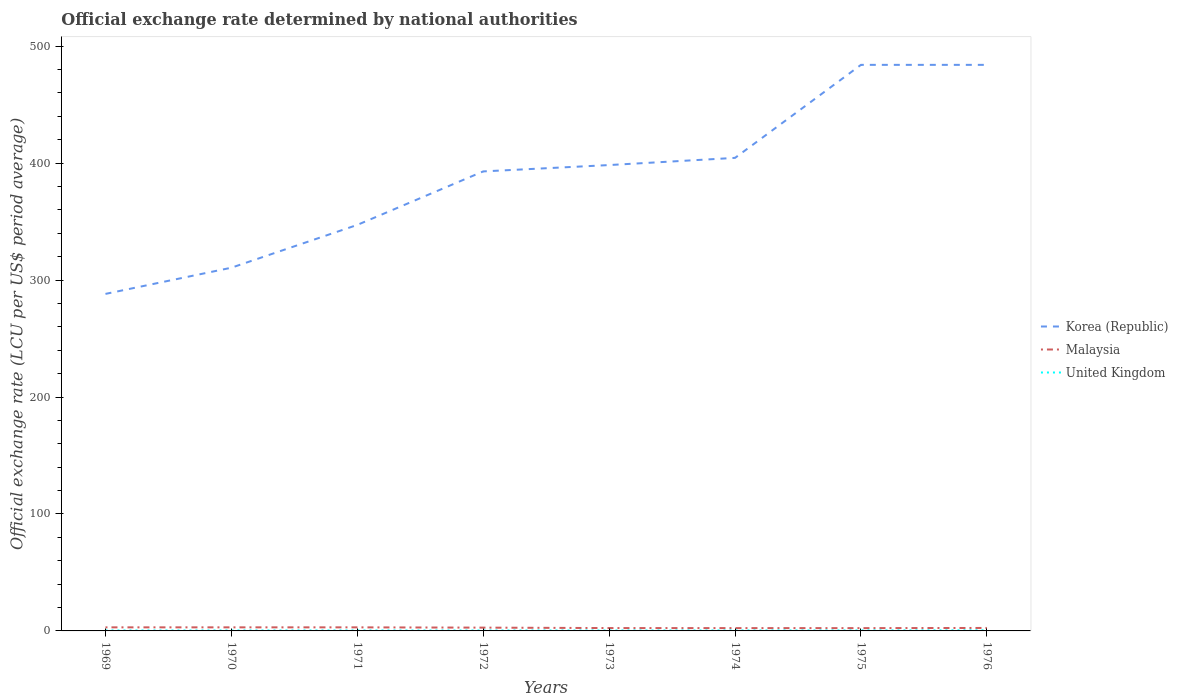How many different coloured lines are there?
Provide a short and direct response. 3. Is the number of lines equal to the number of legend labels?
Offer a very short reply. Yes. Across all years, what is the maximum official exchange rate in Malaysia?
Ensure brevity in your answer.  2.39. In which year was the official exchange rate in Malaysia maximum?
Your answer should be very brief. 1975. What is the total official exchange rate in United Kingdom in the graph?
Ensure brevity in your answer.  -0.02. What is the difference between the highest and the second highest official exchange rate in United Kingdom?
Your response must be concise. 0.16. What is the difference between the highest and the lowest official exchange rate in United Kingdom?
Provide a short and direct response. 2. Is the official exchange rate in Malaysia strictly greater than the official exchange rate in Korea (Republic) over the years?
Your answer should be very brief. Yes. How many years are there in the graph?
Keep it short and to the point. 8. Are the values on the major ticks of Y-axis written in scientific E-notation?
Offer a terse response. No. How many legend labels are there?
Keep it short and to the point. 3. How are the legend labels stacked?
Your response must be concise. Vertical. What is the title of the graph?
Your answer should be compact. Official exchange rate determined by national authorities. What is the label or title of the X-axis?
Your answer should be compact. Years. What is the label or title of the Y-axis?
Your response must be concise. Official exchange rate (LCU per US$ period average). What is the Official exchange rate (LCU per US$ period average) in Korea (Republic) in 1969?
Your response must be concise. 288.16. What is the Official exchange rate (LCU per US$ period average) of Malaysia in 1969?
Ensure brevity in your answer.  3.06. What is the Official exchange rate (LCU per US$ period average) of United Kingdom in 1969?
Provide a succinct answer. 0.42. What is the Official exchange rate (LCU per US$ period average) of Korea (Republic) in 1970?
Ensure brevity in your answer.  310.56. What is the Official exchange rate (LCU per US$ period average) in Malaysia in 1970?
Provide a succinct answer. 3.06. What is the Official exchange rate (LCU per US$ period average) of United Kingdom in 1970?
Provide a short and direct response. 0.42. What is the Official exchange rate (LCU per US$ period average) of Korea (Republic) in 1971?
Offer a terse response. 347.15. What is the Official exchange rate (LCU per US$ period average) in Malaysia in 1971?
Ensure brevity in your answer.  3.05. What is the Official exchange rate (LCU per US$ period average) in United Kingdom in 1971?
Ensure brevity in your answer.  0.41. What is the Official exchange rate (LCU per US$ period average) of Korea (Republic) in 1972?
Provide a short and direct response. 392.89. What is the Official exchange rate (LCU per US$ period average) in Malaysia in 1972?
Make the answer very short. 2.82. What is the Official exchange rate (LCU per US$ period average) in United Kingdom in 1972?
Give a very brief answer. 0.4. What is the Official exchange rate (LCU per US$ period average) in Korea (Republic) in 1973?
Keep it short and to the point. 398.32. What is the Official exchange rate (LCU per US$ period average) in Malaysia in 1973?
Your answer should be very brief. 2.44. What is the Official exchange rate (LCU per US$ period average) of United Kingdom in 1973?
Your response must be concise. 0.41. What is the Official exchange rate (LCU per US$ period average) in Korea (Republic) in 1974?
Provide a short and direct response. 404.47. What is the Official exchange rate (LCU per US$ period average) in Malaysia in 1974?
Your answer should be very brief. 2.41. What is the Official exchange rate (LCU per US$ period average) in United Kingdom in 1974?
Ensure brevity in your answer.  0.43. What is the Official exchange rate (LCU per US$ period average) in Korea (Republic) in 1975?
Offer a very short reply. 484. What is the Official exchange rate (LCU per US$ period average) of Malaysia in 1975?
Offer a terse response. 2.39. What is the Official exchange rate (LCU per US$ period average) of United Kingdom in 1975?
Make the answer very short. 0.45. What is the Official exchange rate (LCU per US$ period average) in Korea (Republic) in 1976?
Your answer should be very brief. 484. What is the Official exchange rate (LCU per US$ period average) in Malaysia in 1976?
Offer a very short reply. 2.54. What is the Official exchange rate (LCU per US$ period average) of United Kingdom in 1976?
Offer a very short reply. 0.56. Across all years, what is the maximum Official exchange rate (LCU per US$ period average) in Korea (Republic)?
Make the answer very short. 484. Across all years, what is the maximum Official exchange rate (LCU per US$ period average) in Malaysia?
Ensure brevity in your answer.  3.06. Across all years, what is the maximum Official exchange rate (LCU per US$ period average) of United Kingdom?
Keep it short and to the point. 0.56. Across all years, what is the minimum Official exchange rate (LCU per US$ period average) of Korea (Republic)?
Your answer should be very brief. 288.16. Across all years, what is the minimum Official exchange rate (LCU per US$ period average) in Malaysia?
Offer a terse response. 2.39. Across all years, what is the minimum Official exchange rate (LCU per US$ period average) of United Kingdom?
Offer a very short reply. 0.4. What is the total Official exchange rate (LCU per US$ period average) in Korea (Republic) in the graph?
Your answer should be very brief. 3109.55. What is the total Official exchange rate (LCU per US$ period average) in Malaysia in the graph?
Your response must be concise. 21.78. What is the total Official exchange rate (LCU per US$ period average) in United Kingdom in the graph?
Keep it short and to the point. 3.49. What is the difference between the Official exchange rate (LCU per US$ period average) in Korea (Republic) in 1969 and that in 1970?
Ensure brevity in your answer.  -22.39. What is the difference between the Official exchange rate (LCU per US$ period average) in Malaysia in 1969 and that in 1970?
Give a very brief answer. 0. What is the difference between the Official exchange rate (LCU per US$ period average) of Korea (Republic) in 1969 and that in 1971?
Make the answer very short. -58.99. What is the difference between the Official exchange rate (LCU per US$ period average) in Malaysia in 1969 and that in 1971?
Make the answer very short. 0.01. What is the difference between the Official exchange rate (LCU per US$ period average) in United Kingdom in 1969 and that in 1971?
Keep it short and to the point. 0.01. What is the difference between the Official exchange rate (LCU per US$ period average) in Korea (Republic) in 1969 and that in 1972?
Give a very brief answer. -104.73. What is the difference between the Official exchange rate (LCU per US$ period average) of Malaysia in 1969 and that in 1972?
Your response must be concise. 0.24. What is the difference between the Official exchange rate (LCU per US$ period average) of United Kingdom in 1969 and that in 1972?
Ensure brevity in your answer.  0.02. What is the difference between the Official exchange rate (LCU per US$ period average) in Korea (Republic) in 1969 and that in 1973?
Offer a very short reply. -110.16. What is the difference between the Official exchange rate (LCU per US$ period average) in Malaysia in 1969 and that in 1973?
Your answer should be compact. 0.62. What is the difference between the Official exchange rate (LCU per US$ period average) in United Kingdom in 1969 and that in 1973?
Offer a very short reply. 0.01. What is the difference between the Official exchange rate (LCU per US$ period average) in Korea (Republic) in 1969 and that in 1974?
Offer a terse response. -116.31. What is the difference between the Official exchange rate (LCU per US$ period average) in Malaysia in 1969 and that in 1974?
Ensure brevity in your answer.  0.65. What is the difference between the Official exchange rate (LCU per US$ period average) in United Kingdom in 1969 and that in 1974?
Provide a short and direct response. -0.01. What is the difference between the Official exchange rate (LCU per US$ period average) of Korea (Republic) in 1969 and that in 1975?
Keep it short and to the point. -195.84. What is the difference between the Official exchange rate (LCU per US$ period average) in Malaysia in 1969 and that in 1975?
Ensure brevity in your answer.  0.67. What is the difference between the Official exchange rate (LCU per US$ period average) of United Kingdom in 1969 and that in 1975?
Your answer should be compact. -0.04. What is the difference between the Official exchange rate (LCU per US$ period average) in Korea (Republic) in 1969 and that in 1976?
Provide a short and direct response. -195.84. What is the difference between the Official exchange rate (LCU per US$ period average) of Malaysia in 1969 and that in 1976?
Give a very brief answer. 0.52. What is the difference between the Official exchange rate (LCU per US$ period average) of United Kingdom in 1969 and that in 1976?
Your answer should be compact. -0.14. What is the difference between the Official exchange rate (LCU per US$ period average) of Korea (Republic) in 1970 and that in 1971?
Keep it short and to the point. -36.59. What is the difference between the Official exchange rate (LCU per US$ period average) of Malaysia in 1970 and that in 1971?
Provide a succinct answer. 0.01. What is the difference between the Official exchange rate (LCU per US$ period average) of United Kingdom in 1970 and that in 1971?
Give a very brief answer. 0.01. What is the difference between the Official exchange rate (LCU per US$ period average) in Korea (Republic) in 1970 and that in 1972?
Keep it short and to the point. -82.34. What is the difference between the Official exchange rate (LCU per US$ period average) of Malaysia in 1970 and that in 1972?
Your answer should be very brief. 0.24. What is the difference between the Official exchange rate (LCU per US$ period average) in United Kingdom in 1970 and that in 1972?
Your answer should be very brief. 0.02. What is the difference between the Official exchange rate (LCU per US$ period average) in Korea (Republic) in 1970 and that in 1973?
Provide a short and direct response. -87.77. What is the difference between the Official exchange rate (LCU per US$ period average) of Malaysia in 1970 and that in 1973?
Offer a very short reply. 0.62. What is the difference between the Official exchange rate (LCU per US$ period average) of United Kingdom in 1970 and that in 1973?
Provide a succinct answer. 0.01. What is the difference between the Official exchange rate (LCU per US$ period average) of Korea (Republic) in 1970 and that in 1974?
Give a very brief answer. -93.92. What is the difference between the Official exchange rate (LCU per US$ period average) in Malaysia in 1970 and that in 1974?
Provide a short and direct response. 0.65. What is the difference between the Official exchange rate (LCU per US$ period average) in United Kingdom in 1970 and that in 1974?
Offer a terse response. -0.01. What is the difference between the Official exchange rate (LCU per US$ period average) of Korea (Republic) in 1970 and that in 1975?
Provide a succinct answer. -173.44. What is the difference between the Official exchange rate (LCU per US$ period average) of Malaysia in 1970 and that in 1975?
Provide a succinct answer. 0.67. What is the difference between the Official exchange rate (LCU per US$ period average) of United Kingdom in 1970 and that in 1975?
Your answer should be compact. -0.04. What is the difference between the Official exchange rate (LCU per US$ period average) of Korea (Republic) in 1970 and that in 1976?
Your answer should be compact. -173.44. What is the difference between the Official exchange rate (LCU per US$ period average) of Malaysia in 1970 and that in 1976?
Ensure brevity in your answer.  0.52. What is the difference between the Official exchange rate (LCU per US$ period average) of United Kingdom in 1970 and that in 1976?
Provide a short and direct response. -0.14. What is the difference between the Official exchange rate (LCU per US$ period average) of Korea (Republic) in 1971 and that in 1972?
Give a very brief answer. -45.75. What is the difference between the Official exchange rate (LCU per US$ period average) of Malaysia in 1971 and that in 1972?
Ensure brevity in your answer.  0.23. What is the difference between the Official exchange rate (LCU per US$ period average) in United Kingdom in 1971 and that in 1972?
Provide a short and direct response. 0.01. What is the difference between the Official exchange rate (LCU per US$ period average) in Korea (Republic) in 1971 and that in 1973?
Provide a short and direct response. -51.17. What is the difference between the Official exchange rate (LCU per US$ period average) in Malaysia in 1971 and that in 1973?
Offer a terse response. 0.61. What is the difference between the Official exchange rate (LCU per US$ period average) in United Kingdom in 1971 and that in 1973?
Provide a short and direct response. 0. What is the difference between the Official exchange rate (LCU per US$ period average) in Korea (Republic) in 1971 and that in 1974?
Give a very brief answer. -57.33. What is the difference between the Official exchange rate (LCU per US$ period average) in Malaysia in 1971 and that in 1974?
Your answer should be compact. 0.65. What is the difference between the Official exchange rate (LCU per US$ period average) of United Kingdom in 1971 and that in 1974?
Ensure brevity in your answer.  -0.02. What is the difference between the Official exchange rate (LCU per US$ period average) in Korea (Republic) in 1971 and that in 1975?
Keep it short and to the point. -136.85. What is the difference between the Official exchange rate (LCU per US$ period average) of Malaysia in 1971 and that in 1975?
Offer a very short reply. 0.66. What is the difference between the Official exchange rate (LCU per US$ period average) in United Kingdom in 1971 and that in 1975?
Provide a short and direct response. -0.04. What is the difference between the Official exchange rate (LCU per US$ period average) in Korea (Republic) in 1971 and that in 1976?
Your answer should be very brief. -136.85. What is the difference between the Official exchange rate (LCU per US$ period average) of Malaysia in 1971 and that in 1976?
Your answer should be compact. 0.51. What is the difference between the Official exchange rate (LCU per US$ period average) of United Kingdom in 1971 and that in 1976?
Offer a very short reply. -0.15. What is the difference between the Official exchange rate (LCU per US$ period average) in Korea (Republic) in 1972 and that in 1973?
Offer a terse response. -5.43. What is the difference between the Official exchange rate (LCU per US$ period average) in Malaysia in 1972 and that in 1973?
Your answer should be compact. 0.38. What is the difference between the Official exchange rate (LCU per US$ period average) in United Kingdom in 1972 and that in 1973?
Your answer should be compact. -0.01. What is the difference between the Official exchange rate (LCU per US$ period average) in Korea (Republic) in 1972 and that in 1974?
Offer a terse response. -11.58. What is the difference between the Official exchange rate (LCU per US$ period average) of Malaysia in 1972 and that in 1974?
Keep it short and to the point. 0.41. What is the difference between the Official exchange rate (LCU per US$ period average) of United Kingdom in 1972 and that in 1974?
Provide a succinct answer. -0.03. What is the difference between the Official exchange rate (LCU per US$ period average) in Korea (Republic) in 1972 and that in 1975?
Provide a short and direct response. -91.11. What is the difference between the Official exchange rate (LCU per US$ period average) in Malaysia in 1972 and that in 1975?
Offer a terse response. 0.43. What is the difference between the Official exchange rate (LCU per US$ period average) in United Kingdom in 1972 and that in 1975?
Offer a very short reply. -0.05. What is the difference between the Official exchange rate (LCU per US$ period average) in Korea (Republic) in 1972 and that in 1976?
Your answer should be compact. -91.11. What is the difference between the Official exchange rate (LCU per US$ period average) in Malaysia in 1972 and that in 1976?
Keep it short and to the point. 0.28. What is the difference between the Official exchange rate (LCU per US$ period average) of United Kingdom in 1972 and that in 1976?
Keep it short and to the point. -0.16. What is the difference between the Official exchange rate (LCU per US$ period average) of Korea (Republic) in 1973 and that in 1974?
Offer a very short reply. -6.15. What is the difference between the Official exchange rate (LCU per US$ period average) of Malaysia in 1973 and that in 1974?
Your answer should be very brief. 0.04. What is the difference between the Official exchange rate (LCU per US$ period average) in United Kingdom in 1973 and that in 1974?
Your response must be concise. -0.02. What is the difference between the Official exchange rate (LCU per US$ period average) of Korea (Republic) in 1973 and that in 1975?
Make the answer very short. -85.68. What is the difference between the Official exchange rate (LCU per US$ period average) of Malaysia in 1973 and that in 1975?
Your answer should be very brief. 0.05. What is the difference between the Official exchange rate (LCU per US$ period average) of United Kingdom in 1973 and that in 1975?
Your response must be concise. -0.04. What is the difference between the Official exchange rate (LCU per US$ period average) in Korea (Republic) in 1973 and that in 1976?
Provide a short and direct response. -85.68. What is the difference between the Official exchange rate (LCU per US$ period average) in Malaysia in 1973 and that in 1976?
Keep it short and to the point. -0.1. What is the difference between the Official exchange rate (LCU per US$ period average) in United Kingdom in 1973 and that in 1976?
Your response must be concise. -0.15. What is the difference between the Official exchange rate (LCU per US$ period average) in Korea (Republic) in 1974 and that in 1975?
Give a very brief answer. -79.53. What is the difference between the Official exchange rate (LCU per US$ period average) of Malaysia in 1974 and that in 1975?
Provide a short and direct response. 0.01. What is the difference between the Official exchange rate (LCU per US$ period average) in United Kingdom in 1974 and that in 1975?
Offer a terse response. -0.02. What is the difference between the Official exchange rate (LCU per US$ period average) of Korea (Republic) in 1974 and that in 1976?
Your answer should be very brief. -79.53. What is the difference between the Official exchange rate (LCU per US$ period average) in Malaysia in 1974 and that in 1976?
Offer a very short reply. -0.13. What is the difference between the Official exchange rate (LCU per US$ period average) in United Kingdom in 1974 and that in 1976?
Your answer should be compact. -0.13. What is the difference between the Official exchange rate (LCU per US$ period average) of Malaysia in 1975 and that in 1976?
Ensure brevity in your answer.  -0.15. What is the difference between the Official exchange rate (LCU per US$ period average) of United Kingdom in 1975 and that in 1976?
Your answer should be very brief. -0.1. What is the difference between the Official exchange rate (LCU per US$ period average) in Korea (Republic) in 1969 and the Official exchange rate (LCU per US$ period average) in Malaysia in 1970?
Provide a short and direct response. 285.1. What is the difference between the Official exchange rate (LCU per US$ period average) of Korea (Republic) in 1969 and the Official exchange rate (LCU per US$ period average) of United Kingdom in 1970?
Offer a very short reply. 287.74. What is the difference between the Official exchange rate (LCU per US$ period average) of Malaysia in 1969 and the Official exchange rate (LCU per US$ period average) of United Kingdom in 1970?
Provide a short and direct response. 2.64. What is the difference between the Official exchange rate (LCU per US$ period average) in Korea (Republic) in 1969 and the Official exchange rate (LCU per US$ period average) in Malaysia in 1971?
Offer a terse response. 285.11. What is the difference between the Official exchange rate (LCU per US$ period average) in Korea (Republic) in 1969 and the Official exchange rate (LCU per US$ period average) in United Kingdom in 1971?
Keep it short and to the point. 287.75. What is the difference between the Official exchange rate (LCU per US$ period average) in Malaysia in 1969 and the Official exchange rate (LCU per US$ period average) in United Kingdom in 1971?
Your answer should be compact. 2.65. What is the difference between the Official exchange rate (LCU per US$ period average) of Korea (Republic) in 1969 and the Official exchange rate (LCU per US$ period average) of Malaysia in 1972?
Provide a succinct answer. 285.34. What is the difference between the Official exchange rate (LCU per US$ period average) of Korea (Republic) in 1969 and the Official exchange rate (LCU per US$ period average) of United Kingdom in 1972?
Make the answer very short. 287.76. What is the difference between the Official exchange rate (LCU per US$ period average) in Malaysia in 1969 and the Official exchange rate (LCU per US$ period average) in United Kingdom in 1972?
Ensure brevity in your answer.  2.66. What is the difference between the Official exchange rate (LCU per US$ period average) in Korea (Republic) in 1969 and the Official exchange rate (LCU per US$ period average) in Malaysia in 1973?
Offer a terse response. 285.72. What is the difference between the Official exchange rate (LCU per US$ period average) in Korea (Republic) in 1969 and the Official exchange rate (LCU per US$ period average) in United Kingdom in 1973?
Offer a very short reply. 287.75. What is the difference between the Official exchange rate (LCU per US$ period average) of Malaysia in 1969 and the Official exchange rate (LCU per US$ period average) of United Kingdom in 1973?
Offer a very short reply. 2.65. What is the difference between the Official exchange rate (LCU per US$ period average) in Korea (Republic) in 1969 and the Official exchange rate (LCU per US$ period average) in Malaysia in 1974?
Offer a terse response. 285.75. What is the difference between the Official exchange rate (LCU per US$ period average) of Korea (Republic) in 1969 and the Official exchange rate (LCU per US$ period average) of United Kingdom in 1974?
Give a very brief answer. 287.73. What is the difference between the Official exchange rate (LCU per US$ period average) in Malaysia in 1969 and the Official exchange rate (LCU per US$ period average) in United Kingdom in 1974?
Your answer should be compact. 2.63. What is the difference between the Official exchange rate (LCU per US$ period average) in Korea (Republic) in 1969 and the Official exchange rate (LCU per US$ period average) in Malaysia in 1975?
Keep it short and to the point. 285.77. What is the difference between the Official exchange rate (LCU per US$ period average) of Korea (Republic) in 1969 and the Official exchange rate (LCU per US$ period average) of United Kingdom in 1975?
Provide a succinct answer. 287.71. What is the difference between the Official exchange rate (LCU per US$ period average) in Malaysia in 1969 and the Official exchange rate (LCU per US$ period average) in United Kingdom in 1975?
Your response must be concise. 2.61. What is the difference between the Official exchange rate (LCU per US$ period average) in Korea (Republic) in 1969 and the Official exchange rate (LCU per US$ period average) in Malaysia in 1976?
Provide a succinct answer. 285.62. What is the difference between the Official exchange rate (LCU per US$ period average) of Korea (Republic) in 1969 and the Official exchange rate (LCU per US$ period average) of United Kingdom in 1976?
Keep it short and to the point. 287.6. What is the difference between the Official exchange rate (LCU per US$ period average) of Malaysia in 1969 and the Official exchange rate (LCU per US$ period average) of United Kingdom in 1976?
Ensure brevity in your answer.  2.5. What is the difference between the Official exchange rate (LCU per US$ period average) in Korea (Republic) in 1970 and the Official exchange rate (LCU per US$ period average) in Malaysia in 1971?
Offer a terse response. 307.5. What is the difference between the Official exchange rate (LCU per US$ period average) in Korea (Republic) in 1970 and the Official exchange rate (LCU per US$ period average) in United Kingdom in 1971?
Offer a terse response. 310.14. What is the difference between the Official exchange rate (LCU per US$ period average) of Malaysia in 1970 and the Official exchange rate (LCU per US$ period average) of United Kingdom in 1971?
Provide a short and direct response. 2.65. What is the difference between the Official exchange rate (LCU per US$ period average) of Korea (Republic) in 1970 and the Official exchange rate (LCU per US$ period average) of Malaysia in 1972?
Offer a very short reply. 307.74. What is the difference between the Official exchange rate (LCU per US$ period average) in Korea (Republic) in 1970 and the Official exchange rate (LCU per US$ period average) in United Kingdom in 1972?
Ensure brevity in your answer.  310.16. What is the difference between the Official exchange rate (LCU per US$ period average) of Malaysia in 1970 and the Official exchange rate (LCU per US$ period average) of United Kingdom in 1972?
Ensure brevity in your answer.  2.66. What is the difference between the Official exchange rate (LCU per US$ period average) in Korea (Republic) in 1970 and the Official exchange rate (LCU per US$ period average) in Malaysia in 1973?
Make the answer very short. 308.11. What is the difference between the Official exchange rate (LCU per US$ period average) in Korea (Republic) in 1970 and the Official exchange rate (LCU per US$ period average) in United Kingdom in 1973?
Your response must be concise. 310.15. What is the difference between the Official exchange rate (LCU per US$ period average) in Malaysia in 1970 and the Official exchange rate (LCU per US$ period average) in United Kingdom in 1973?
Give a very brief answer. 2.65. What is the difference between the Official exchange rate (LCU per US$ period average) in Korea (Republic) in 1970 and the Official exchange rate (LCU per US$ period average) in Malaysia in 1974?
Offer a very short reply. 308.15. What is the difference between the Official exchange rate (LCU per US$ period average) of Korea (Republic) in 1970 and the Official exchange rate (LCU per US$ period average) of United Kingdom in 1974?
Give a very brief answer. 310.13. What is the difference between the Official exchange rate (LCU per US$ period average) in Malaysia in 1970 and the Official exchange rate (LCU per US$ period average) in United Kingdom in 1974?
Provide a succinct answer. 2.63. What is the difference between the Official exchange rate (LCU per US$ period average) in Korea (Republic) in 1970 and the Official exchange rate (LCU per US$ period average) in Malaysia in 1975?
Provide a succinct answer. 308.16. What is the difference between the Official exchange rate (LCU per US$ period average) of Korea (Republic) in 1970 and the Official exchange rate (LCU per US$ period average) of United Kingdom in 1975?
Keep it short and to the point. 310.1. What is the difference between the Official exchange rate (LCU per US$ period average) in Malaysia in 1970 and the Official exchange rate (LCU per US$ period average) in United Kingdom in 1975?
Your answer should be compact. 2.61. What is the difference between the Official exchange rate (LCU per US$ period average) of Korea (Republic) in 1970 and the Official exchange rate (LCU per US$ period average) of Malaysia in 1976?
Offer a terse response. 308.01. What is the difference between the Official exchange rate (LCU per US$ period average) in Korea (Republic) in 1970 and the Official exchange rate (LCU per US$ period average) in United Kingdom in 1976?
Ensure brevity in your answer.  310. What is the difference between the Official exchange rate (LCU per US$ period average) in Malaysia in 1970 and the Official exchange rate (LCU per US$ period average) in United Kingdom in 1976?
Offer a very short reply. 2.5. What is the difference between the Official exchange rate (LCU per US$ period average) of Korea (Republic) in 1971 and the Official exchange rate (LCU per US$ period average) of Malaysia in 1972?
Your response must be concise. 344.33. What is the difference between the Official exchange rate (LCU per US$ period average) in Korea (Republic) in 1971 and the Official exchange rate (LCU per US$ period average) in United Kingdom in 1972?
Provide a short and direct response. 346.75. What is the difference between the Official exchange rate (LCU per US$ period average) of Malaysia in 1971 and the Official exchange rate (LCU per US$ period average) of United Kingdom in 1972?
Provide a succinct answer. 2.65. What is the difference between the Official exchange rate (LCU per US$ period average) in Korea (Republic) in 1971 and the Official exchange rate (LCU per US$ period average) in Malaysia in 1973?
Your answer should be compact. 344.7. What is the difference between the Official exchange rate (LCU per US$ period average) of Korea (Republic) in 1971 and the Official exchange rate (LCU per US$ period average) of United Kingdom in 1973?
Ensure brevity in your answer.  346.74. What is the difference between the Official exchange rate (LCU per US$ period average) of Malaysia in 1971 and the Official exchange rate (LCU per US$ period average) of United Kingdom in 1973?
Your answer should be compact. 2.64. What is the difference between the Official exchange rate (LCU per US$ period average) of Korea (Republic) in 1971 and the Official exchange rate (LCU per US$ period average) of Malaysia in 1974?
Ensure brevity in your answer.  344.74. What is the difference between the Official exchange rate (LCU per US$ period average) of Korea (Republic) in 1971 and the Official exchange rate (LCU per US$ period average) of United Kingdom in 1974?
Offer a very short reply. 346.72. What is the difference between the Official exchange rate (LCU per US$ period average) of Malaysia in 1971 and the Official exchange rate (LCU per US$ period average) of United Kingdom in 1974?
Provide a succinct answer. 2.62. What is the difference between the Official exchange rate (LCU per US$ period average) in Korea (Republic) in 1971 and the Official exchange rate (LCU per US$ period average) in Malaysia in 1975?
Your response must be concise. 344.75. What is the difference between the Official exchange rate (LCU per US$ period average) in Korea (Republic) in 1971 and the Official exchange rate (LCU per US$ period average) in United Kingdom in 1975?
Make the answer very short. 346.7. What is the difference between the Official exchange rate (LCU per US$ period average) in Malaysia in 1971 and the Official exchange rate (LCU per US$ period average) in United Kingdom in 1975?
Make the answer very short. 2.6. What is the difference between the Official exchange rate (LCU per US$ period average) in Korea (Republic) in 1971 and the Official exchange rate (LCU per US$ period average) in Malaysia in 1976?
Your answer should be compact. 344.61. What is the difference between the Official exchange rate (LCU per US$ period average) in Korea (Republic) in 1971 and the Official exchange rate (LCU per US$ period average) in United Kingdom in 1976?
Your response must be concise. 346.59. What is the difference between the Official exchange rate (LCU per US$ period average) of Malaysia in 1971 and the Official exchange rate (LCU per US$ period average) of United Kingdom in 1976?
Make the answer very short. 2.5. What is the difference between the Official exchange rate (LCU per US$ period average) in Korea (Republic) in 1972 and the Official exchange rate (LCU per US$ period average) in Malaysia in 1973?
Your response must be concise. 390.45. What is the difference between the Official exchange rate (LCU per US$ period average) of Korea (Republic) in 1972 and the Official exchange rate (LCU per US$ period average) of United Kingdom in 1973?
Give a very brief answer. 392.49. What is the difference between the Official exchange rate (LCU per US$ period average) in Malaysia in 1972 and the Official exchange rate (LCU per US$ period average) in United Kingdom in 1973?
Your answer should be compact. 2.41. What is the difference between the Official exchange rate (LCU per US$ period average) in Korea (Republic) in 1972 and the Official exchange rate (LCU per US$ period average) in Malaysia in 1974?
Your answer should be compact. 390.49. What is the difference between the Official exchange rate (LCU per US$ period average) in Korea (Republic) in 1972 and the Official exchange rate (LCU per US$ period average) in United Kingdom in 1974?
Ensure brevity in your answer.  392.47. What is the difference between the Official exchange rate (LCU per US$ period average) in Malaysia in 1972 and the Official exchange rate (LCU per US$ period average) in United Kingdom in 1974?
Provide a succinct answer. 2.39. What is the difference between the Official exchange rate (LCU per US$ period average) in Korea (Republic) in 1972 and the Official exchange rate (LCU per US$ period average) in Malaysia in 1975?
Offer a terse response. 390.5. What is the difference between the Official exchange rate (LCU per US$ period average) of Korea (Republic) in 1972 and the Official exchange rate (LCU per US$ period average) of United Kingdom in 1975?
Provide a succinct answer. 392.44. What is the difference between the Official exchange rate (LCU per US$ period average) of Malaysia in 1972 and the Official exchange rate (LCU per US$ period average) of United Kingdom in 1975?
Provide a short and direct response. 2.37. What is the difference between the Official exchange rate (LCU per US$ period average) of Korea (Republic) in 1972 and the Official exchange rate (LCU per US$ period average) of Malaysia in 1976?
Offer a terse response. 390.35. What is the difference between the Official exchange rate (LCU per US$ period average) of Korea (Republic) in 1972 and the Official exchange rate (LCU per US$ period average) of United Kingdom in 1976?
Provide a succinct answer. 392.34. What is the difference between the Official exchange rate (LCU per US$ period average) of Malaysia in 1972 and the Official exchange rate (LCU per US$ period average) of United Kingdom in 1976?
Provide a succinct answer. 2.26. What is the difference between the Official exchange rate (LCU per US$ period average) of Korea (Republic) in 1973 and the Official exchange rate (LCU per US$ period average) of Malaysia in 1974?
Provide a short and direct response. 395.91. What is the difference between the Official exchange rate (LCU per US$ period average) in Korea (Republic) in 1973 and the Official exchange rate (LCU per US$ period average) in United Kingdom in 1974?
Provide a succinct answer. 397.89. What is the difference between the Official exchange rate (LCU per US$ period average) in Malaysia in 1973 and the Official exchange rate (LCU per US$ period average) in United Kingdom in 1974?
Make the answer very short. 2.02. What is the difference between the Official exchange rate (LCU per US$ period average) of Korea (Republic) in 1973 and the Official exchange rate (LCU per US$ period average) of Malaysia in 1975?
Offer a very short reply. 395.93. What is the difference between the Official exchange rate (LCU per US$ period average) of Korea (Republic) in 1973 and the Official exchange rate (LCU per US$ period average) of United Kingdom in 1975?
Your answer should be very brief. 397.87. What is the difference between the Official exchange rate (LCU per US$ period average) of Malaysia in 1973 and the Official exchange rate (LCU per US$ period average) of United Kingdom in 1975?
Provide a short and direct response. 1.99. What is the difference between the Official exchange rate (LCU per US$ period average) in Korea (Republic) in 1973 and the Official exchange rate (LCU per US$ period average) in Malaysia in 1976?
Ensure brevity in your answer.  395.78. What is the difference between the Official exchange rate (LCU per US$ period average) of Korea (Republic) in 1973 and the Official exchange rate (LCU per US$ period average) of United Kingdom in 1976?
Your answer should be very brief. 397.77. What is the difference between the Official exchange rate (LCU per US$ period average) in Malaysia in 1973 and the Official exchange rate (LCU per US$ period average) in United Kingdom in 1976?
Keep it short and to the point. 1.89. What is the difference between the Official exchange rate (LCU per US$ period average) in Korea (Republic) in 1974 and the Official exchange rate (LCU per US$ period average) in Malaysia in 1975?
Make the answer very short. 402.08. What is the difference between the Official exchange rate (LCU per US$ period average) of Korea (Republic) in 1974 and the Official exchange rate (LCU per US$ period average) of United Kingdom in 1975?
Your answer should be compact. 404.02. What is the difference between the Official exchange rate (LCU per US$ period average) of Malaysia in 1974 and the Official exchange rate (LCU per US$ period average) of United Kingdom in 1975?
Your response must be concise. 1.96. What is the difference between the Official exchange rate (LCU per US$ period average) in Korea (Republic) in 1974 and the Official exchange rate (LCU per US$ period average) in Malaysia in 1976?
Ensure brevity in your answer.  401.93. What is the difference between the Official exchange rate (LCU per US$ period average) in Korea (Republic) in 1974 and the Official exchange rate (LCU per US$ period average) in United Kingdom in 1976?
Your answer should be compact. 403.92. What is the difference between the Official exchange rate (LCU per US$ period average) of Malaysia in 1974 and the Official exchange rate (LCU per US$ period average) of United Kingdom in 1976?
Provide a succinct answer. 1.85. What is the difference between the Official exchange rate (LCU per US$ period average) in Korea (Republic) in 1975 and the Official exchange rate (LCU per US$ period average) in Malaysia in 1976?
Make the answer very short. 481.46. What is the difference between the Official exchange rate (LCU per US$ period average) of Korea (Republic) in 1975 and the Official exchange rate (LCU per US$ period average) of United Kingdom in 1976?
Offer a very short reply. 483.44. What is the difference between the Official exchange rate (LCU per US$ period average) of Malaysia in 1975 and the Official exchange rate (LCU per US$ period average) of United Kingdom in 1976?
Your answer should be very brief. 1.84. What is the average Official exchange rate (LCU per US$ period average) of Korea (Republic) per year?
Your answer should be very brief. 388.69. What is the average Official exchange rate (LCU per US$ period average) in Malaysia per year?
Your response must be concise. 2.72. What is the average Official exchange rate (LCU per US$ period average) in United Kingdom per year?
Offer a terse response. 0.44. In the year 1969, what is the difference between the Official exchange rate (LCU per US$ period average) of Korea (Republic) and Official exchange rate (LCU per US$ period average) of Malaysia?
Offer a terse response. 285.1. In the year 1969, what is the difference between the Official exchange rate (LCU per US$ period average) of Korea (Republic) and Official exchange rate (LCU per US$ period average) of United Kingdom?
Your response must be concise. 287.74. In the year 1969, what is the difference between the Official exchange rate (LCU per US$ period average) of Malaysia and Official exchange rate (LCU per US$ period average) of United Kingdom?
Keep it short and to the point. 2.64. In the year 1970, what is the difference between the Official exchange rate (LCU per US$ period average) in Korea (Republic) and Official exchange rate (LCU per US$ period average) in Malaysia?
Offer a terse response. 307.49. In the year 1970, what is the difference between the Official exchange rate (LCU per US$ period average) of Korea (Republic) and Official exchange rate (LCU per US$ period average) of United Kingdom?
Provide a succinct answer. 310.14. In the year 1970, what is the difference between the Official exchange rate (LCU per US$ period average) in Malaysia and Official exchange rate (LCU per US$ period average) in United Kingdom?
Offer a very short reply. 2.64. In the year 1971, what is the difference between the Official exchange rate (LCU per US$ period average) in Korea (Republic) and Official exchange rate (LCU per US$ period average) in Malaysia?
Ensure brevity in your answer.  344.1. In the year 1971, what is the difference between the Official exchange rate (LCU per US$ period average) in Korea (Republic) and Official exchange rate (LCU per US$ period average) in United Kingdom?
Offer a terse response. 346.74. In the year 1971, what is the difference between the Official exchange rate (LCU per US$ period average) of Malaysia and Official exchange rate (LCU per US$ period average) of United Kingdom?
Your response must be concise. 2.64. In the year 1972, what is the difference between the Official exchange rate (LCU per US$ period average) in Korea (Republic) and Official exchange rate (LCU per US$ period average) in Malaysia?
Offer a terse response. 390.07. In the year 1972, what is the difference between the Official exchange rate (LCU per US$ period average) of Korea (Republic) and Official exchange rate (LCU per US$ period average) of United Kingdom?
Keep it short and to the point. 392.49. In the year 1972, what is the difference between the Official exchange rate (LCU per US$ period average) in Malaysia and Official exchange rate (LCU per US$ period average) in United Kingdom?
Your answer should be very brief. 2.42. In the year 1973, what is the difference between the Official exchange rate (LCU per US$ period average) in Korea (Republic) and Official exchange rate (LCU per US$ period average) in Malaysia?
Give a very brief answer. 395.88. In the year 1973, what is the difference between the Official exchange rate (LCU per US$ period average) in Korea (Republic) and Official exchange rate (LCU per US$ period average) in United Kingdom?
Ensure brevity in your answer.  397.91. In the year 1973, what is the difference between the Official exchange rate (LCU per US$ period average) of Malaysia and Official exchange rate (LCU per US$ period average) of United Kingdom?
Provide a succinct answer. 2.04. In the year 1974, what is the difference between the Official exchange rate (LCU per US$ period average) in Korea (Republic) and Official exchange rate (LCU per US$ period average) in Malaysia?
Provide a short and direct response. 402.07. In the year 1974, what is the difference between the Official exchange rate (LCU per US$ period average) of Korea (Republic) and Official exchange rate (LCU per US$ period average) of United Kingdom?
Keep it short and to the point. 404.04. In the year 1974, what is the difference between the Official exchange rate (LCU per US$ period average) in Malaysia and Official exchange rate (LCU per US$ period average) in United Kingdom?
Ensure brevity in your answer.  1.98. In the year 1975, what is the difference between the Official exchange rate (LCU per US$ period average) of Korea (Republic) and Official exchange rate (LCU per US$ period average) of Malaysia?
Your response must be concise. 481.61. In the year 1975, what is the difference between the Official exchange rate (LCU per US$ period average) in Korea (Republic) and Official exchange rate (LCU per US$ period average) in United Kingdom?
Give a very brief answer. 483.55. In the year 1975, what is the difference between the Official exchange rate (LCU per US$ period average) of Malaysia and Official exchange rate (LCU per US$ period average) of United Kingdom?
Your answer should be very brief. 1.94. In the year 1976, what is the difference between the Official exchange rate (LCU per US$ period average) in Korea (Republic) and Official exchange rate (LCU per US$ period average) in Malaysia?
Your answer should be very brief. 481.46. In the year 1976, what is the difference between the Official exchange rate (LCU per US$ period average) in Korea (Republic) and Official exchange rate (LCU per US$ period average) in United Kingdom?
Your answer should be very brief. 483.44. In the year 1976, what is the difference between the Official exchange rate (LCU per US$ period average) in Malaysia and Official exchange rate (LCU per US$ period average) in United Kingdom?
Provide a short and direct response. 1.99. What is the ratio of the Official exchange rate (LCU per US$ period average) in Korea (Republic) in 1969 to that in 1970?
Give a very brief answer. 0.93. What is the ratio of the Official exchange rate (LCU per US$ period average) of Malaysia in 1969 to that in 1970?
Provide a short and direct response. 1. What is the ratio of the Official exchange rate (LCU per US$ period average) in United Kingdom in 1969 to that in 1970?
Your response must be concise. 1. What is the ratio of the Official exchange rate (LCU per US$ period average) in Korea (Republic) in 1969 to that in 1971?
Ensure brevity in your answer.  0.83. What is the ratio of the Official exchange rate (LCU per US$ period average) of Korea (Republic) in 1969 to that in 1972?
Your answer should be very brief. 0.73. What is the ratio of the Official exchange rate (LCU per US$ period average) in Malaysia in 1969 to that in 1972?
Your response must be concise. 1.09. What is the ratio of the Official exchange rate (LCU per US$ period average) in United Kingdom in 1969 to that in 1972?
Make the answer very short. 1.04. What is the ratio of the Official exchange rate (LCU per US$ period average) of Korea (Republic) in 1969 to that in 1973?
Provide a short and direct response. 0.72. What is the ratio of the Official exchange rate (LCU per US$ period average) of Malaysia in 1969 to that in 1973?
Give a very brief answer. 1.25. What is the ratio of the Official exchange rate (LCU per US$ period average) in United Kingdom in 1969 to that in 1973?
Your answer should be compact. 1.02. What is the ratio of the Official exchange rate (LCU per US$ period average) of Korea (Republic) in 1969 to that in 1974?
Offer a very short reply. 0.71. What is the ratio of the Official exchange rate (LCU per US$ period average) of Malaysia in 1969 to that in 1974?
Give a very brief answer. 1.27. What is the ratio of the Official exchange rate (LCU per US$ period average) in United Kingdom in 1969 to that in 1974?
Ensure brevity in your answer.  0.97. What is the ratio of the Official exchange rate (LCU per US$ period average) in Korea (Republic) in 1969 to that in 1975?
Offer a terse response. 0.6. What is the ratio of the Official exchange rate (LCU per US$ period average) of Malaysia in 1969 to that in 1975?
Your answer should be compact. 1.28. What is the ratio of the Official exchange rate (LCU per US$ period average) of United Kingdom in 1969 to that in 1975?
Your response must be concise. 0.92. What is the ratio of the Official exchange rate (LCU per US$ period average) in Korea (Republic) in 1969 to that in 1976?
Keep it short and to the point. 0.6. What is the ratio of the Official exchange rate (LCU per US$ period average) of Malaysia in 1969 to that in 1976?
Give a very brief answer. 1.2. What is the ratio of the Official exchange rate (LCU per US$ period average) of United Kingdom in 1969 to that in 1976?
Provide a succinct answer. 0.75. What is the ratio of the Official exchange rate (LCU per US$ period average) of Korea (Republic) in 1970 to that in 1971?
Provide a short and direct response. 0.89. What is the ratio of the Official exchange rate (LCU per US$ period average) in Malaysia in 1970 to that in 1971?
Ensure brevity in your answer.  1. What is the ratio of the Official exchange rate (LCU per US$ period average) in Korea (Republic) in 1970 to that in 1972?
Your answer should be compact. 0.79. What is the ratio of the Official exchange rate (LCU per US$ period average) in Malaysia in 1970 to that in 1972?
Make the answer very short. 1.09. What is the ratio of the Official exchange rate (LCU per US$ period average) of United Kingdom in 1970 to that in 1972?
Your answer should be very brief. 1.04. What is the ratio of the Official exchange rate (LCU per US$ period average) in Korea (Republic) in 1970 to that in 1973?
Offer a terse response. 0.78. What is the ratio of the Official exchange rate (LCU per US$ period average) of Malaysia in 1970 to that in 1973?
Your response must be concise. 1.25. What is the ratio of the Official exchange rate (LCU per US$ period average) in United Kingdom in 1970 to that in 1973?
Provide a succinct answer. 1.02. What is the ratio of the Official exchange rate (LCU per US$ period average) in Korea (Republic) in 1970 to that in 1974?
Make the answer very short. 0.77. What is the ratio of the Official exchange rate (LCU per US$ period average) in Malaysia in 1970 to that in 1974?
Ensure brevity in your answer.  1.27. What is the ratio of the Official exchange rate (LCU per US$ period average) in United Kingdom in 1970 to that in 1974?
Offer a terse response. 0.97. What is the ratio of the Official exchange rate (LCU per US$ period average) of Korea (Republic) in 1970 to that in 1975?
Keep it short and to the point. 0.64. What is the ratio of the Official exchange rate (LCU per US$ period average) of Malaysia in 1970 to that in 1975?
Provide a succinct answer. 1.28. What is the ratio of the Official exchange rate (LCU per US$ period average) of United Kingdom in 1970 to that in 1975?
Give a very brief answer. 0.92. What is the ratio of the Official exchange rate (LCU per US$ period average) in Korea (Republic) in 1970 to that in 1976?
Give a very brief answer. 0.64. What is the ratio of the Official exchange rate (LCU per US$ period average) in Malaysia in 1970 to that in 1976?
Give a very brief answer. 1.2. What is the ratio of the Official exchange rate (LCU per US$ period average) in United Kingdom in 1970 to that in 1976?
Give a very brief answer. 0.75. What is the ratio of the Official exchange rate (LCU per US$ period average) in Korea (Republic) in 1971 to that in 1972?
Offer a very short reply. 0.88. What is the ratio of the Official exchange rate (LCU per US$ period average) of Malaysia in 1971 to that in 1972?
Ensure brevity in your answer.  1.08. What is the ratio of the Official exchange rate (LCU per US$ period average) of United Kingdom in 1971 to that in 1972?
Offer a terse response. 1.03. What is the ratio of the Official exchange rate (LCU per US$ period average) of Korea (Republic) in 1971 to that in 1973?
Your answer should be very brief. 0.87. What is the ratio of the Official exchange rate (LCU per US$ period average) in Malaysia in 1971 to that in 1973?
Provide a succinct answer. 1.25. What is the ratio of the Official exchange rate (LCU per US$ period average) of United Kingdom in 1971 to that in 1973?
Your answer should be very brief. 1.01. What is the ratio of the Official exchange rate (LCU per US$ period average) in Korea (Republic) in 1971 to that in 1974?
Your answer should be compact. 0.86. What is the ratio of the Official exchange rate (LCU per US$ period average) in Malaysia in 1971 to that in 1974?
Offer a very short reply. 1.27. What is the ratio of the Official exchange rate (LCU per US$ period average) in United Kingdom in 1971 to that in 1974?
Offer a very short reply. 0.96. What is the ratio of the Official exchange rate (LCU per US$ period average) of Korea (Republic) in 1971 to that in 1975?
Your answer should be compact. 0.72. What is the ratio of the Official exchange rate (LCU per US$ period average) in Malaysia in 1971 to that in 1975?
Ensure brevity in your answer.  1.28. What is the ratio of the Official exchange rate (LCU per US$ period average) in United Kingdom in 1971 to that in 1975?
Give a very brief answer. 0.91. What is the ratio of the Official exchange rate (LCU per US$ period average) in Korea (Republic) in 1971 to that in 1976?
Provide a short and direct response. 0.72. What is the ratio of the Official exchange rate (LCU per US$ period average) in Malaysia in 1971 to that in 1976?
Your answer should be very brief. 1.2. What is the ratio of the Official exchange rate (LCU per US$ period average) of United Kingdom in 1971 to that in 1976?
Offer a very short reply. 0.74. What is the ratio of the Official exchange rate (LCU per US$ period average) in Korea (Republic) in 1972 to that in 1973?
Provide a short and direct response. 0.99. What is the ratio of the Official exchange rate (LCU per US$ period average) in Malaysia in 1972 to that in 1973?
Make the answer very short. 1.15. What is the ratio of the Official exchange rate (LCU per US$ period average) of United Kingdom in 1972 to that in 1973?
Your response must be concise. 0.98. What is the ratio of the Official exchange rate (LCU per US$ period average) in Korea (Republic) in 1972 to that in 1974?
Ensure brevity in your answer.  0.97. What is the ratio of the Official exchange rate (LCU per US$ period average) of Malaysia in 1972 to that in 1974?
Your answer should be very brief. 1.17. What is the ratio of the Official exchange rate (LCU per US$ period average) of United Kingdom in 1972 to that in 1974?
Make the answer very short. 0.94. What is the ratio of the Official exchange rate (LCU per US$ period average) in Korea (Republic) in 1972 to that in 1975?
Your answer should be very brief. 0.81. What is the ratio of the Official exchange rate (LCU per US$ period average) in Malaysia in 1972 to that in 1975?
Keep it short and to the point. 1.18. What is the ratio of the Official exchange rate (LCU per US$ period average) of United Kingdom in 1972 to that in 1975?
Your answer should be compact. 0.89. What is the ratio of the Official exchange rate (LCU per US$ period average) in Korea (Republic) in 1972 to that in 1976?
Ensure brevity in your answer.  0.81. What is the ratio of the Official exchange rate (LCU per US$ period average) in Malaysia in 1972 to that in 1976?
Offer a terse response. 1.11. What is the ratio of the Official exchange rate (LCU per US$ period average) in United Kingdom in 1972 to that in 1976?
Your response must be concise. 0.72. What is the ratio of the Official exchange rate (LCU per US$ period average) of Korea (Republic) in 1973 to that in 1974?
Ensure brevity in your answer.  0.98. What is the ratio of the Official exchange rate (LCU per US$ period average) in Malaysia in 1973 to that in 1974?
Give a very brief answer. 1.02. What is the ratio of the Official exchange rate (LCU per US$ period average) of United Kingdom in 1973 to that in 1974?
Your response must be concise. 0.95. What is the ratio of the Official exchange rate (LCU per US$ period average) in Korea (Republic) in 1973 to that in 1975?
Make the answer very short. 0.82. What is the ratio of the Official exchange rate (LCU per US$ period average) of Malaysia in 1973 to that in 1975?
Provide a succinct answer. 1.02. What is the ratio of the Official exchange rate (LCU per US$ period average) in United Kingdom in 1973 to that in 1975?
Keep it short and to the point. 0.9. What is the ratio of the Official exchange rate (LCU per US$ period average) of Korea (Republic) in 1973 to that in 1976?
Your answer should be very brief. 0.82. What is the ratio of the Official exchange rate (LCU per US$ period average) in Malaysia in 1973 to that in 1976?
Offer a very short reply. 0.96. What is the ratio of the Official exchange rate (LCU per US$ period average) of United Kingdom in 1973 to that in 1976?
Provide a succinct answer. 0.73. What is the ratio of the Official exchange rate (LCU per US$ period average) in Korea (Republic) in 1974 to that in 1975?
Your response must be concise. 0.84. What is the ratio of the Official exchange rate (LCU per US$ period average) in Malaysia in 1974 to that in 1975?
Your answer should be very brief. 1.01. What is the ratio of the Official exchange rate (LCU per US$ period average) in United Kingdom in 1974 to that in 1975?
Ensure brevity in your answer.  0.95. What is the ratio of the Official exchange rate (LCU per US$ period average) in Korea (Republic) in 1974 to that in 1976?
Keep it short and to the point. 0.84. What is the ratio of the Official exchange rate (LCU per US$ period average) of Malaysia in 1974 to that in 1976?
Give a very brief answer. 0.95. What is the ratio of the Official exchange rate (LCU per US$ period average) in United Kingdom in 1974 to that in 1976?
Offer a terse response. 0.77. What is the ratio of the Official exchange rate (LCU per US$ period average) in Korea (Republic) in 1975 to that in 1976?
Provide a short and direct response. 1. What is the ratio of the Official exchange rate (LCU per US$ period average) of Malaysia in 1975 to that in 1976?
Offer a terse response. 0.94. What is the ratio of the Official exchange rate (LCU per US$ period average) in United Kingdom in 1975 to that in 1976?
Your response must be concise. 0.81. What is the difference between the highest and the second highest Official exchange rate (LCU per US$ period average) in United Kingdom?
Provide a short and direct response. 0.1. What is the difference between the highest and the lowest Official exchange rate (LCU per US$ period average) of Korea (Republic)?
Give a very brief answer. 195.84. What is the difference between the highest and the lowest Official exchange rate (LCU per US$ period average) in Malaysia?
Your answer should be very brief. 0.67. What is the difference between the highest and the lowest Official exchange rate (LCU per US$ period average) in United Kingdom?
Ensure brevity in your answer.  0.16. 